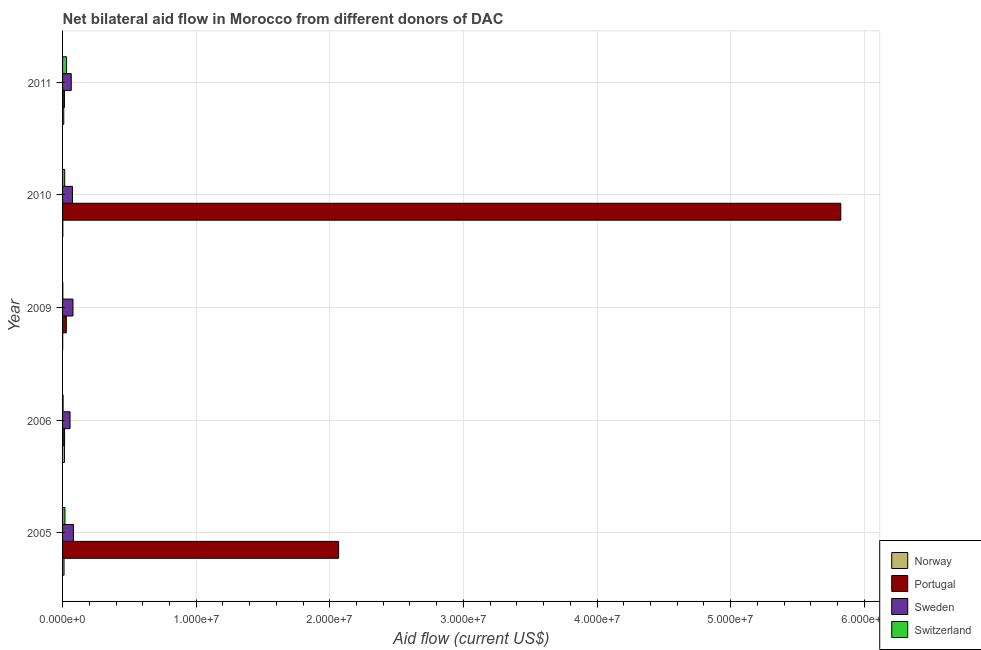How many groups of bars are there?
Offer a terse response. 5. Are the number of bars per tick equal to the number of legend labels?
Provide a short and direct response. Yes. How many bars are there on the 3rd tick from the top?
Give a very brief answer. 4. In how many cases, is the number of bars for a given year not equal to the number of legend labels?
Keep it short and to the point. 0. What is the amount of aid given by sweden in 2009?
Offer a terse response. 7.80e+05. Across all years, what is the maximum amount of aid given by portugal?
Ensure brevity in your answer.  5.82e+07. Across all years, what is the minimum amount of aid given by sweden?
Your answer should be very brief. 5.60e+05. In which year was the amount of aid given by portugal minimum?
Keep it short and to the point. 2011. What is the total amount of aid given by norway in the graph?
Make the answer very short. 3.70e+05. What is the difference between the amount of aid given by sweden in 2006 and that in 2011?
Make the answer very short. -9.00e+04. What is the difference between the amount of aid given by norway in 2010 and the amount of aid given by portugal in 2005?
Provide a succinct answer. -2.06e+07. What is the average amount of aid given by sweden per year?
Provide a short and direct response. 7.08e+05. In the year 2011, what is the difference between the amount of aid given by portugal and amount of aid given by sweden?
Keep it short and to the point. -5.10e+05. In how many years, is the amount of aid given by sweden greater than 12000000 US$?
Your answer should be compact. 0. What is the ratio of the amount of aid given by portugal in 2009 to that in 2010?
Your answer should be compact. 0.01. Is the amount of aid given by norway in 2005 less than that in 2009?
Make the answer very short. No. What is the difference between the highest and the second highest amount of aid given by sweden?
Your response must be concise. 3.00e+04. What is the difference between the highest and the lowest amount of aid given by portugal?
Provide a succinct answer. 5.81e+07. In how many years, is the amount of aid given by sweden greater than the average amount of aid given by sweden taken over all years?
Provide a succinct answer. 3. Is the sum of the amount of aid given by sweden in 2009 and 2011 greater than the maximum amount of aid given by portugal across all years?
Make the answer very short. No. Is it the case that in every year, the sum of the amount of aid given by sweden and amount of aid given by portugal is greater than the sum of amount of aid given by norway and amount of aid given by switzerland?
Your response must be concise. No. What does the 2nd bar from the top in 2006 represents?
Offer a terse response. Sweden. What does the 3rd bar from the bottom in 2011 represents?
Your answer should be compact. Sweden. Are all the bars in the graph horizontal?
Your answer should be very brief. Yes. Are the values on the major ticks of X-axis written in scientific E-notation?
Offer a terse response. Yes. Does the graph contain grids?
Provide a succinct answer. Yes. Where does the legend appear in the graph?
Your answer should be compact. Bottom right. What is the title of the graph?
Your response must be concise. Net bilateral aid flow in Morocco from different donors of DAC. Does "Tertiary education" appear as one of the legend labels in the graph?
Your response must be concise. No. What is the label or title of the Y-axis?
Provide a short and direct response. Year. What is the Aid flow (current US$) of Norway in 2005?
Your answer should be very brief. 1.10e+05. What is the Aid flow (current US$) in Portugal in 2005?
Ensure brevity in your answer.  2.07e+07. What is the Aid flow (current US$) of Sweden in 2005?
Provide a succinct answer. 8.10e+05. What is the Aid flow (current US$) of Portugal in 2006?
Offer a terse response. 1.50e+05. What is the Aid flow (current US$) in Sweden in 2006?
Your answer should be very brief. 5.60e+05. What is the Aid flow (current US$) in Norway in 2009?
Your answer should be compact. 10000. What is the Aid flow (current US$) of Sweden in 2009?
Give a very brief answer. 7.80e+05. What is the Aid flow (current US$) of Portugal in 2010?
Offer a very short reply. 5.82e+07. What is the Aid flow (current US$) of Sweden in 2010?
Offer a very short reply. 7.40e+05. What is the Aid flow (current US$) of Norway in 2011?
Offer a terse response. 9.00e+04. What is the Aid flow (current US$) of Sweden in 2011?
Ensure brevity in your answer.  6.50e+05. Across all years, what is the maximum Aid flow (current US$) of Norway?
Provide a short and direct response. 1.40e+05. Across all years, what is the maximum Aid flow (current US$) of Portugal?
Give a very brief answer. 5.82e+07. Across all years, what is the maximum Aid flow (current US$) of Sweden?
Provide a short and direct response. 8.10e+05. Across all years, what is the minimum Aid flow (current US$) in Sweden?
Make the answer very short. 5.60e+05. Across all years, what is the minimum Aid flow (current US$) of Switzerland?
Give a very brief answer. 2.00e+04. What is the total Aid flow (current US$) of Norway in the graph?
Offer a terse response. 3.70e+05. What is the total Aid flow (current US$) in Portugal in the graph?
Keep it short and to the point. 7.95e+07. What is the total Aid flow (current US$) of Sweden in the graph?
Your answer should be very brief. 3.54e+06. What is the difference between the Aid flow (current US$) in Norway in 2005 and that in 2006?
Provide a succinct answer. -3.00e+04. What is the difference between the Aid flow (current US$) of Portugal in 2005 and that in 2006?
Make the answer very short. 2.05e+07. What is the difference between the Aid flow (current US$) in Sweden in 2005 and that in 2006?
Your answer should be compact. 2.50e+05. What is the difference between the Aid flow (current US$) of Norway in 2005 and that in 2009?
Keep it short and to the point. 1.00e+05. What is the difference between the Aid flow (current US$) in Portugal in 2005 and that in 2009?
Provide a succinct answer. 2.04e+07. What is the difference between the Aid flow (current US$) of Sweden in 2005 and that in 2009?
Ensure brevity in your answer.  3.00e+04. What is the difference between the Aid flow (current US$) of Portugal in 2005 and that in 2010?
Your response must be concise. -3.76e+07. What is the difference between the Aid flow (current US$) of Portugal in 2005 and that in 2011?
Your answer should be very brief. 2.05e+07. What is the difference between the Aid flow (current US$) in Portugal in 2006 and that in 2009?
Offer a very short reply. -1.30e+05. What is the difference between the Aid flow (current US$) in Sweden in 2006 and that in 2009?
Your answer should be compact. -2.20e+05. What is the difference between the Aid flow (current US$) in Switzerland in 2006 and that in 2009?
Your response must be concise. 2.00e+04. What is the difference between the Aid flow (current US$) in Norway in 2006 and that in 2010?
Your answer should be very brief. 1.20e+05. What is the difference between the Aid flow (current US$) of Portugal in 2006 and that in 2010?
Offer a very short reply. -5.81e+07. What is the difference between the Aid flow (current US$) in Switzerland in 2006 and that in 2010?
Give a very brief answer. -1.20e+05. What is the difference between the Aid flow (current US$) of Portugal in 2006 and that in 2011?
Your answer should be very brief. 10000. What is the difference between the Aid flow (current US$) of Norway in 2009 and that in 2010?
Your answer should be very brief. -10000. What is the difference between the Aid flow (current US$) in Portugal in 2009 and that in 2010?
Your answer should be compact. -5.80e+07. What is the difference between the Aid flow (current US$) in Switzerland in 2009 and that in 2010?
Provide a short and direct response. -1.40e+05. What is the difference between the Aid flow (current US$) of Norway in 2009 and that in 2011?
Give a very brief answer. -8.00e+04. What is the difference between the Aid flow (current US$) in Sweden in 2009 and that in 2011?
Offer a terse response. 1.30e+05. What is the difference between the Aid flow (current US$) in Switzerland in 2009 and that in 2011?
Your answer should be compact. -2.80e+05. What is the difference between the Aid flow (current US$) of Norway in 2010 and that in 2011?
Offer a terse response. -7.00e+04. What is the difference between the Aid flow (current US$) of Portugal in 2010 and that in 2011?
Give a very brief answer. 5.81e+07. What is the difference between the Aid flow (current US$) of Sweden in 2010 and that in 2011?
Offer a very short reply. 9.00e+04. What is the difference between the Aid flow (current US$) in Switzerland in 2010 and that in 2011?
Make the answer very short. -1.40e+05. What is the difference between the Aid flow (current US$) in Norway in 2005 and the Aid flow (current US$) in Portugal in 2006?
Provide a succinct answer. -4.00e+04. What is the difference between the Aid flow (current US$) of Norway in 2005 and the Aid flow (current US$) of Sweden in 2006?
Offer a terse response. -4.50e+05. What is the difference between the Aid flow (current US$) of Portugal in 2005 and the Aid flow (current US$) of Sweden in 2006?
Your answer should be compact. 2.01e+07. What is the difference between the Aid flow (current US$) of Portugal in 2005 and the Aid flow (current US$) of Switzerland in 2006?
Provide a short and direct response. 2.06e+07. What is the difference between the Aid flow (current US$) of Sweden in 2005 and the Aid flow (current US$) of Switzerland in 2006?
Ensure brevity in your answer.  7.70e+05. What is the difference between the Aid flow (current US$) in Norway in 2005 and the Aid flow (current US$) in Portugal in 2009?
Offer a terse response. -1.70e+05. What is the difference between the Aid flow (current US$) of Norway in 2005 and the Aid flow (current US$) of Sweden in 2009?
Provide a succinct answer. -6.70e+05. What is the difference between the Aid flow (current US$) in Portugal in 2005 and the Aid flow (current US$) in Sweden in 2009?
Give a very brief answer. 1.99e+07. What is the difference between the Aid flow (current US$) in Portugal in 2005 and the Aid flow (current US$) in Switzerland in 2009?
Provide a short and direct response. 2.06e+07. What is the difference between the Aid flow (current US$) in Sweden in 2005 and the Aid flow (current US$) in Switzerland in 2009?
Your answer should be very brief. 7.90e+05. What is the difference between the Aid flow (current US$) of Norway in 2005 and the Aid flow (current US$) of Portugal in 2010?
Give a very brief answer. -5.81e+07. What is the difference between the Aid flow (current US$) in Norway in 2005 and the Aid flow (current US$) in Sweden in 2010?
Offer a terse response. -6.30e+05. What is the difference between the Aid flow (current US$) in Portugal in 2005 and the Aid flow (current US$) in Sweden in 2010?
Offer a terse response. 1.99e+07. What is the difference between the Aid flow (current US$) in Portugal in 2005 and the Aid flow (current US$) in Switzerland in 2010?
Give a very brief answer. 2.05e+07. What is the difference between the Aid flow (current US$) in Sweden in 2005 and the Aid flow (current US$) in Switzerland in 2010?
Offer a terse response. 6.50e+05. What is the difference between the Aid flow (current US$) of Norway in 2005 and the Aid flow (current US$) of Sweden in 2011?
Give a very brief answer. -5.40e+05. What is the difference between the Aid flow (current US$) of Portugal in 2005 and the Aid flow (current US$) of Sweden in 2011?
Make the answer very short. 2.00e+07. What is the difference between the Aid flow (current US$) in Portugal in 2005 and the Aid flow (current US$) in Switzerland in 2011?
Keep it short and to the point. 2.04e+07. What is the difference between the Aid flow (current US$) in Sweden in 2005 and the Aid flow (current US$) in Switzerland in 2011?
Provide a succinct answer. 5.10e+05. What is the difference between the Aid flow (current US$) in Norway in 2006 and the Aid flow (current US$) in Sweden in 2009?
Offer a terse response. -6.40e+05. What is the difference between the Aid flow (current US$) of Portugal in 2006 and the Aid flow (current US$) of Sweden in 2009?
Make the answer very short. -6.30e+05. What is the difference between the Aid flow (current US$) in Portugal in 2006 and the Aid flow (current US$) in Switzerland in 2009?
Your answer should be very brief. 1.30e+05. What is the difference between the Aid flow (current US$) of Sweden in 2006 and the Aid flow (current US$) of Switzerland in 2009?
Your response must be concise. 5.40e+05. What is the difference between the Aid flow (current US$) in Norway in 2006 and the Aid flow (current US$) in Portugal in 2010?
Offer a terse response. -5.81e+07. What is the difference between the Aid flow (current US$) of Norway in 2006 and the Aid flow (current US$) of Sweden in 2010?
Your answer should be very brief. -6.00e+05. What is the difference between the Aid flow (current US$) in Portugal in 2006 and the Aid flow (current US$) in Sweden in 2010?
Provide a succinct answer. -5.90e+05. What is the difference between the Aid flow (current US$) in Sweden in 2006 and the Aid flow (current US$) in Switzerland in 2010?
Provide a succinct answer. 4.00e+05. What is the difference between the Aid flow (current US$) of Norway in 2006 and the Aid flow (current US$) of Sweden in 2011?
Provide a short and direct response. -5.10e+05. What is the difference between the Aid flow (current US$) in Portugal in 2006 and the Aid flow (current US$) in Sweden in 2011?
Offer a very short reply. -5.00e+05. What is the difference between the Aid flow (current US$) of Portugal in 2006 and the Aid flow (current US$) of Switzerland in 2011?
Your answer should be very brief. -1.50e+05. What is the difference between the Aid flow (current US$) in Norway in 2009 and the Aid flow (current US$) in Portugal in 2010?
Provide a succinct answer. -5.82e+07. What is the difference between the Aid flow (current US$) in Norway in 2009 and the Aid flow (current US$) in Sweden in 2010?
Offer a very short reply. -7.30e+05. What is the difference between the Aid flow (current US$) of Portugal in 2009 and the Aid flow (current US$) of Sweden in 2010?
Offer a very short reply. -4.60e+05. What is the difference between the Aid flow (current US$) of Sweden in 2009 and the Aid flow (current US$) of Switzerland in 2010?
Give a very brief answer. 6.20e+05. What is the difference between the Aid flow (current US$) in Norway in 2009 and the Aid flow (current US$) in Portugal in 2011?
Provide a succinct answer. -1.30e+05. What is the difference between the Aid flow (current US$) of Norway in 2009 and the Aid flow (current US$) of Sweden in 2011?
Provide a short and direct response. -6.40e+05. What is the difference between the Aid flow (current US$) in Portugal in 2009 and the Aid flow (current US$) in Sweden in 2011?
Offer a very short reply. -3.70e+05. What is the difference between the Aid flow (current US$) in Sweden in 2009 and the Aid flow (current US$) in Switzerland in 2011?
Keep it short and to the point. 4.80e+05. What is the difference between the Aid flow (current US$) of Norway in 2010 and the Aid flow (current US$) of Portugal in 2011?
Make the answer very short. -1.20e+05. What is the difference between the Aid flow (current US$) of Norway in 2010 and the Aid flow (current US$) of Sweden in 2011?
Offer a terse response. -6.30e+05. What is the difference between the Aid flow (current US$) of Norway in 2010 and the Aid flow (current US$) of Switzerland in 2011?
Provide a short and direct response. -2.80e+05. What is the difference between the Aid flow (current US$) of Portugal in 2010 and the Aid flow (current US$) of Sweden in 2011?
Ensure brevity in your answer.  5.76e+07. What is the difference between the Aid flow (current US$) of Portugal in 2010 and the Aid flow (current US$) of Switzerland in 2011?
Keep it short and to the point. 5.79e+07. What is the difference between the Aid flow (current US$) in Sweden in 2010 and the Aid flow (current US$) in Switzerland in 2011?
Make the answer very short. 4.40e+05. What is the average Aid flow (current US$) of Norway per year?
Keep it short and to the point. 7.40e+04. What is the average Aid flow (current US$) in Portugal per year?
Make the answer very short. 1.59e+07. What is the average Aid flow (current US$) of Sweden per year?
Keep it short and to the point. 7.08e+05. In the year 2005, what is the difference between the Aid flow (current US$) in Norway and Aid flow (current US$) in Portugal?
Offer a very short reply. -2.06e+07. In the year 2005, what is the difference between the Aid flow (current US$) of Norway and Aid flow (current US$) of Sweden?
Your answer should be very brief. -7.00e+05. In the year 2005, what is the difference between the Aid flow (current US$) of Portugal and Aid flow (current US$) of Sweden?
Provide a succinct answer. 1.98e+07. In the year 2005, what is the difference between the Aid flow (current US$) in Portugal and Aid flow (current US$) in Switzerland?
Keep it short and to the point. 2.05e+07. In the year 2005, what is the difference between the Aid flow (current US$) of Sweden and Aid flow (current US$) of Switzerland?
Your answer should be very brief. 6.30e+05. In the year 2006, what is the difference between the Aid flow (current US$) of Norway and Aid flow (current US$) of Sweden?
Give a very brief answer. -4.20e+05. In the year 2006, what is the difference between the Aid flow (current US$) in Portugal and Aid flow (current US$) in Sweden?
Ensure brevity in your answer.  -4.10e+05. In the year 2006, what is the difference between the Aid flow (current US$) of Portugal and Aid flow (current US$) of Switzerland?
Offer a very short reply. 1.10e+05. In the year 2006, what is the difference between the Aid flow (current US$) of Sweden and Aid flow (current US$) of Switzerland?
Offer a terse response. 5.20e+05. In the year 2009, what is the difference between the Aid flow (current US$) of Norway and Aid flow (current US$) of Portugal?
Make the answer very short. -2.70e+05. In the year 2009, what is the difference between the Aid flow (current US$) in Norway and Aid flow (current US$) in Sweden?
Your answer should be very brief. -7.70e+05. In the year 2009, what is the difference between the Aid flow (current US$) in Norway and Aid flow (current US$) in Switzerland?
Offer a terse response. -10000. In the year 2009, what is the difference between the Aid flow (current US$) in Portugal and Aid flow (current US$) in Sweden?
Offer a terse response. -5.00e+05. In the year 2009, what is the difference between the Aid flow (current US$) in Sweden and Aid flow (current US$) in Switzerland?
Offer a very short reply. 7.60e+05. In the year 2010, what is the difference between the Aid flow (current US$) in Norway and Aid flow (current US$) in Portugal?
Provide a short and direct response. -5.82e+07. In the year 2010, what is the difference between the Aid flow (current US$) of Norway and Aid flow (current US$) of Sweden?
Ensure brevity in your answer.  -7.20e+05. In the year 2010, what is the difference between the Aid flow (current US$) of Portugal and Aid flow (current US$) of Sweden?
Provide a short and direct response. 5.75e+07. In the year 2010, what is the difference between the Aid flow (current US$) of Portugal and Aid flow (current US$) of Switzerland?
Your answer should be very brief. 5.81e+07. In the year 2010, what is the difference between the Aid flow (current US$) in Sweden and Aid flow (current US$) in Switzerland?
Ensure brevity in your answer.  5.80e+05. In the year 2011, what is the difference between the Aid flow (current US$) of Norway and Aid flow (current US$) of Sweden?
Ensure brevity in your answer.  -5.60e+05. In the year 2011, what is the difference between the Aid flow (current US$) in Portugal and Aid flow (current US$) in Sweden?
Offer a very short reply. -5.10e+05. What is the ratio of the Aid flow (current US$) in Norway in 2005 to that in 2006?
Provide a short and direct response. 0.79. What is the ratio of the Aid flow (current US$) in Portugal in 2005 to that in 2006?
Offer a terse response. 137.73. What is the ratio of the Aid flow (current US$) in Sweden in 2005 to that in 2006?
Offer a terse response. 1.45. What is the ratio of the Aid flow (current US$) in Norway in 2005 to that in 2009?
Provide a succinct answer. 11. What is the ratio of the Aid flow (current US$) in Portugal in 2005 to that in 2009?
Ensure brevity in your answer.  73.79. What is the ratio of the Aid flow (current US$) in Portugal in 2005 to that in 2010?
Make the answer very short. 0.35. What is the ratio of the Aid flow (current US$) of Sweden in 2005 to that in 2010?
Your response must be concise. 1.09. What is the ratio of the Aid flow (current US$) in Norway in 2005 to that in 2011?
Your response must be concise. 1.22. What is the ratio of the Aid flow (current US$) in Portugal in 2005 to that in 2011?
Provide a short and direct response. 147.57. What is the ratio of the Aid flow (current US$) in Sweden in 2005 to that in 2011?
Give a very brief answer. 1.25. What is the ratio of the Aid flow (current US$) in Switzerland in 2005 to that in 2011?
Keep it short and to the point. 0.6. What is the ratio of the Aid flow (current US$) in Portugal in 2006 to that in 2009?
Keep it short and to the point. 0.54. What is the ratio of the Aid flow (current US$) in Sweden in 2006 to that in 2009?
Ensure brevity in your answer.  0.72. What is the ratio of the Aid flow (current US$) in Norway in 2006 to that in 2010?
Your response must be concise. 7. What is the ratio of the Aid flow (current US$) of Portugal in 2006 to that in 2010?
Your answer should be compact. 0. What is the ratio of the Aid flow (current US$) in Sweden in 2006 to that in 2010?
Provide a short and direct response. 0.76. What is the ratio of the Aid flow (current US$) in Switzerland in 2006 to that in 2010?
Provide a short and direct response. 0.25. What is the ratio of the Aid flow (current US$) in Norway in 2006 to that in 2011?
Your answer should be compact. 1.56. What is the ratio of the Aid flow (current US$) in Portugal in 2006 to that in 2011?
Give a very brief answer. 1.07. What is the ratio of the Aid flow (current US$) in Sweden in 2006 to that in 2011?
Your response must be concise. 0.86. What is the ratio of the Aid flow (current US$) in Switzerland in 2006 to that in 2011?
Ensure brevity in your answer.  0.13. What is the ratio of the Aid flow (current US$) of Portugal in 2009 to that in 2010?
Your answer should be very brief. 0. What is the ratio of the Aid flow (current US$) in Sweden in 2009 to that in 2010?
Your answer should be compact. 1.05. What is the ratio of the Aid flow (current US$) in Switzerland in 2009 to that in 2010?
Ensure brevity in your answer.  0.12. What is the ratio of the Aid flow (current US$) of Portugal in 2009 to that in 2011?
Your response must be concise. 2. What is the ratio of the Aid flow (current US$) of Switzerland in 2009 to that in 2011?
Your answer should be very brief. 0.07. What is the ratio of the Aid flow (current US$) of Norway in 2010 to that in 2011?
Make the answer very short. 0.22. What is the ratio of the Aid flow (current US$) in Portugal in 2010 to that in 2011?
Offer a terse response. 416. What is the ratio of the Aid flow (current US$) in Sweden in 2010 to that in 2011?
Make the answer very short. 1.14. What is the ratio of the Aid flow (current US$) of Switzerland in 2010 to that in 2011?
Make the answer very short. 0.53. What is the difference between the highest and the second highest Aid flow (current US$) in Portugal?
Offer a very short reply. 3.76e+07. What is the difference between the highest and the second highest Aid flow (current US$) of Sweden?
Make the answer very short. 3.00e+04. What is the difference between the highest and the second highest Aid flow (current US$) of Switzerland?
Make the answer very short. 1.20e+05. What is the difference between the highest and the lowest Aid flow (current US$) in Portugal?
Offer a terse response. 5.81e+07. 